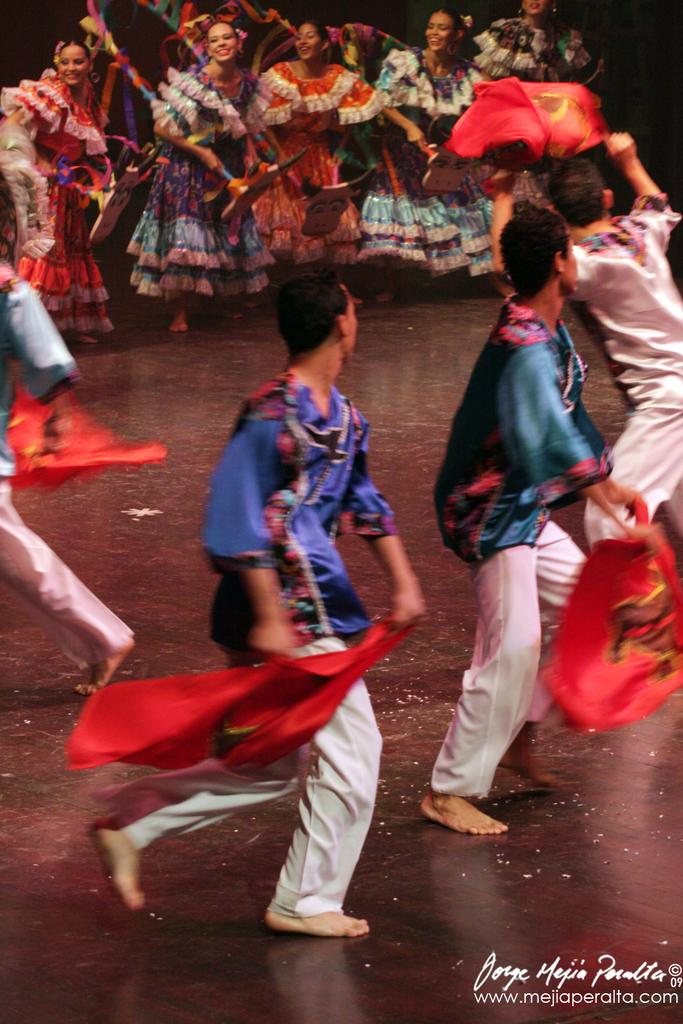What are the people in the image doing? The people in the image are dancing. Where is the dancing taking place? The dancing is taking place on a floor. Is there any text visible in the image? Yes, there is some text visible in the bottom right corner of the image. What type of mint is being used as a prop by the dancers in the image? There is no mint present in the image, and the dancers are not using any props. What color are the trousers worn by the dancers in the image? The provided facts do not mention the color or type of clothing worn by the dancers. Can you describe the pot used for cooking in the image? There is no pot present in the image. 